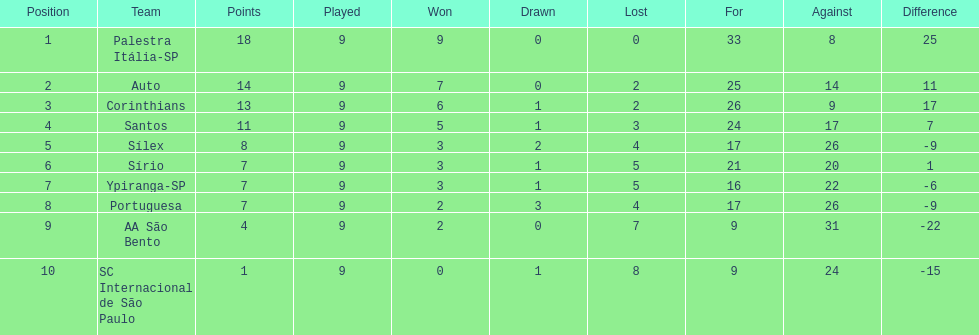Which brazilian team secured the first place in the 1926 brazilian football cup? Palestra Itália-SP. Give me the full table as a dictionary. {'header': ['Position', 'Team', 'Points', 'Played', 'Won', 'Drawn', 'Lost', 'For', 'Against', 'Difference'], 'rows': [['1', 'Palestra Itália-SP', '18', '9', '9', '0', '0', '33', '8', '25'], ['2', 'Auto', '14', '9', '7', '0', '2', '25', '14', '11'], ['3', 'Corinthians', '13', '9', '6', '1', '2', '26', '9', '17'], ['4', 'Santos', '11', '9', '5', '1', '3', '24', '17', '7'], ['5', 'Sílex', '8', '9', '3', '2', '4', '17', '26', '-9'], ['6', 'Sírio', '7', '9', '3', '1', '5', '21', '20', '1'], ['7', 'Ypiranga-SP', '7', '9', '3', '1', '5', '16', '22', '-6'], ['8', 'Portuguesa', '7', '9', '2', '3', '4', '17', '26', '-9'], ['9', 'AA São Bento', '4', '9', '2', '0', '7', '9', '31', '-22'], ['10', 'SC Internacional de São Paulo', '1', '9', '0', '1', '8', '9', '24', '-15']]} 